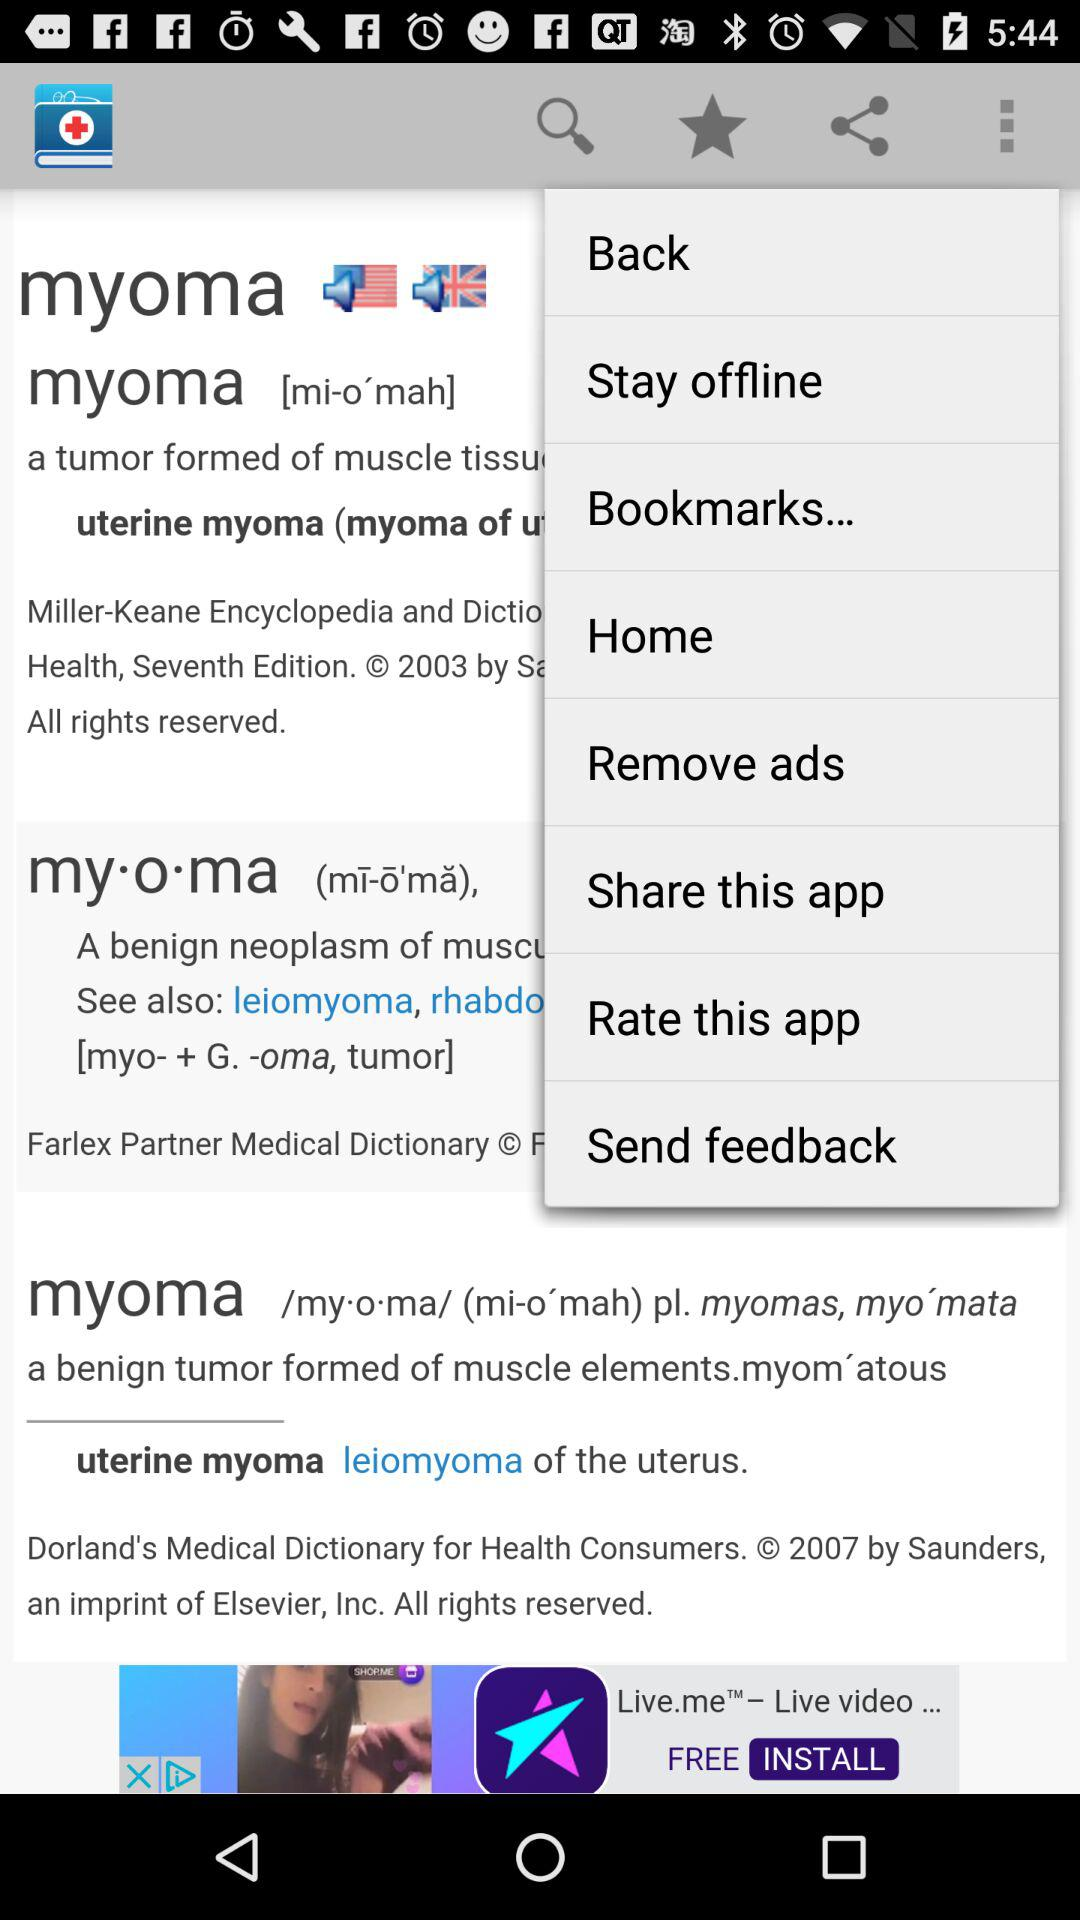How many flags are on the screen? The question seems to be referencing an image that does not display flags, but rather shows a smartphone screen with a definition of the term 'myoma'. Therefore, there are no flags present on this screen. 